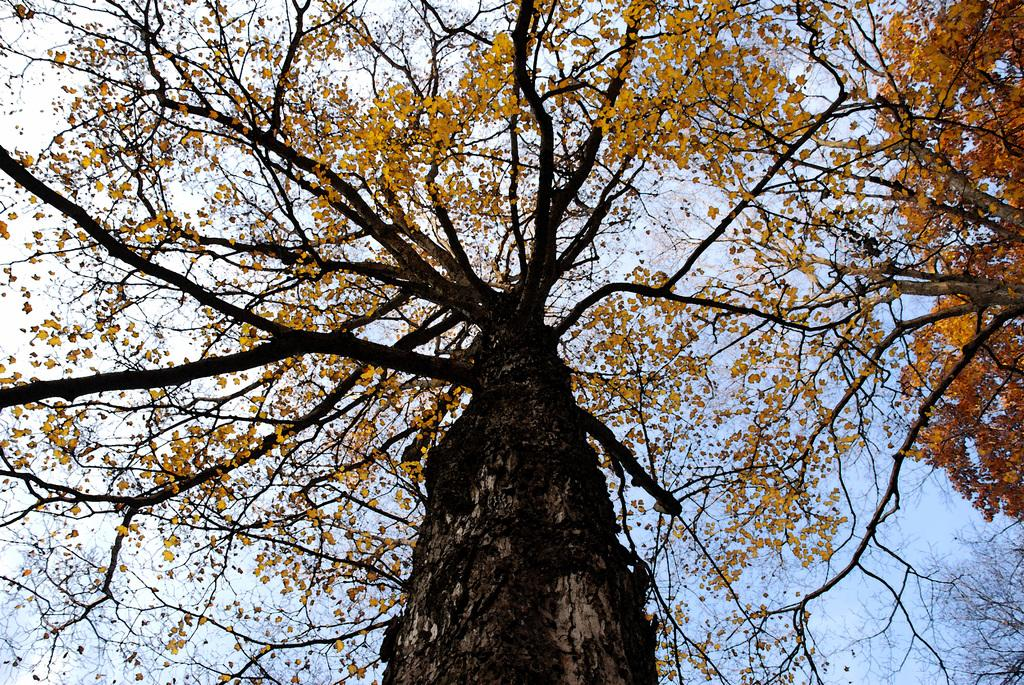What type of vegetation can be seen in the image? There are trees in the image. What part of the natural environment is visible in the image? The sky is visible in the background of the image. What type of distribution service is being offered by the trees in the image? There is no distribution service being offered by the trees in the image; they are simply trees in a natural environment. 